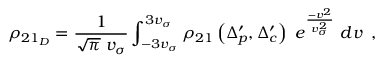<formula> <loc_0><loc_0><loc_500><loc_500>\rho _ { 2 1 _ { D } } = \frac { 1 } { \sqrt { \pi } \, v _ { \sigma } } \int _ { - 3 v _ { \sigma } } ^ { 3 v _ { \sigma } } \rho _ { 2 1 } \left ( \Delta _ { p } ^ { \prime } , \Delta _ { c } ^ { \prime } \right ) \, e ^ { \frac { - v ^ { 2 } } { v _ { \sigma } ^ { 2 } } } \, d v \, ,</formula> 